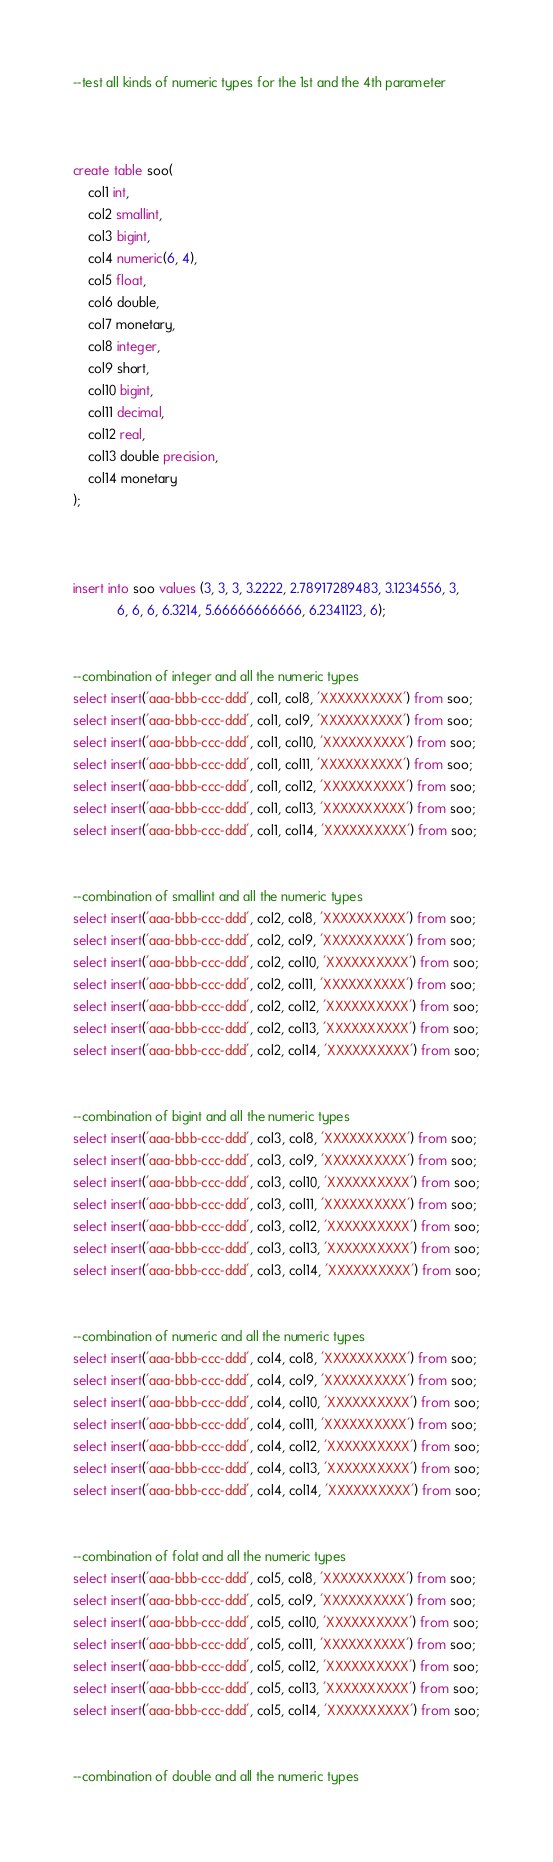<code> <loc_0><loc_0><loc_500><loc_500><_SQL_>--test all kinds of numeric types for the 1st and the 4th parameter



create table soo(
	col1 int,
	col2 smallint,
	col3 bigint,
	col4 numeric(6, 4),
	col5 float,
	col6 double,
	col7 monetary,
	col8 integer,
	col9 short,
	col10 bigint,
	col11 decimal,
	col12 real,
	col13 double precision,
	col14 monetary
);



insert into soo values (3, 3, 3, 3.2222, 2.78917289483, 3.1234556, 3,
			6, 6, 6, 6.3214, 5.66666666666, 6.2341123, 6);


--combination of integer and all the numeric types
select insert('aaa-bbb-ccc-ddd', col1, col8, 'XXXXXXXXXX') from soo;
select insert('aaa-bbb-ccc-ddd', col1, col9, 'XXXXXXXXXX') from soo;
select insert('aaa-bbb-ccc-ddd', col1, col10, 'XXXXXXXXXX') from soo;
select insert('aaa-bbb-ccc-ddd', col1, col11, 'XXXXXXXXXX') from soo;
select insert('aaa-bbb-ccc-ddd', col1, col12, 'XXXXXXXXXX') from soo;
select insert('aaa-bbb-ccc-ddd', col1, col13, 'XXXXXXXXXX') from soo;
select insert('aaa-bbb-ccc-ddd', col1, col14, 'XXXXXXXXXX') from soo;


--combination of smallint and all the numeric types
select insert('aaa-bbb-ccc-ddd', col2, col8, 'XXXXXXXXXX') from soo;
select insert('aaa-bbb-ccc-ddd', col2, col9, 'XXXXXXXXXX') from soo;
select insert('aaa-bbb-ccc-ddd', col2, col10, 'XXXXXXXXXX') from soo;
select insert('aaa-bbb-ccc-ddd', col2, col11, 'XXXXXXXXXX') from soo;
select insert('aaa-bbb-ccc-ddd', col2, col12, 'XXXXXXXXXX') from soo;
select insert('aaa-bbb-ccc-ddd', col2, col13, 'XXXXXXXXXX') from soo;
select insert('aaa-bbb-ccc-ddd', col2, col14, 'XXXXXXXXXX') from soo;


--combination of bigint and all the numeric types
select insert('aaa-bbb-ccc-ddd', col3, col8, 'XXXXXXXXXX') from soo;
select insert('aaa-bbb-ccc-ddd', col3, col9, 'XXXXXXXXXX') from soo;
select insert('aaa-bbb-ccc-ddd', col3, col10, 'XXXXXXXXXX') from soo;
select insert('aaa-bbb-ccc-ddd', col3, col11, 'XXXXXXXXXX') from soo;
select insert('aaa-bbb-ccc-ddd', col3, col12, 'XXXXXXXXXX') from soo;
select insert('aaa-bbb-ccc-ddd', col3, col13, 'XXXXXXXXXX') from soo;
select insert('aaa-bbb-ccc-ddd', col3, col14, 'XXXXXXXXXX') from soo;


--combination of numeric and all the numeric types
select insert('aaa-bbb-ccc-ddd', col4, col8, 'XXXXXXXXXX') from soo;
select insert('aaa-bbb-ccc-ddd', col4, col9, 'XXXXXXXXXX') from soo;
select insert('aaa-bbb-ccc-ddd', col4, col10, 'XXXXXXXXXX') from soo;
select insert('aaa-bbb-ccc-ddd', col4, col11, 'XXXXXXXXXX') from soo;
select insert('aaa-bbb-ccc-ddd', col4, col12, 'XXXXXXXXXX') from soo;
select insert('aaa-bbb-ccc-ddd', col4, col13, 'XXXXXXXXXX') from soo;
select insert('aaa-bbb-ccc-ddd', col4, col14, 'XXXXXXXXXX') from soo;


--combination of folat and all the numeric types
select insert('aaa-bbb-ccc-ddd', col5, col8, 'XXXXXXXXXX') from soo;
select insert('aaa-bbb-ccc-ddd', col5, col9, 'XXXXXXXXXX') from soo;
select insert('aaa-bbb-ccc-ddd', col5, col10, 'XXXXXXXXXX') from soo;
select insert('aaa-bbb-ccc-ddd', col5, col11, 'XXXXXXXXXX') from soo;
select insert('aaa-bbb-ccc-ddd', col5, col12, 'XXXXXXXXXX') from soo;
select insert('aaa-bbb-ccc-ddd', col5, col13, 'XXXXXXXXXX') from soo;
select insert('aaa-bbb-ccc-ddd', col5, col14, 'XXXXXXXXXX') from soo;


--combination of double and all the numeric types</code> 